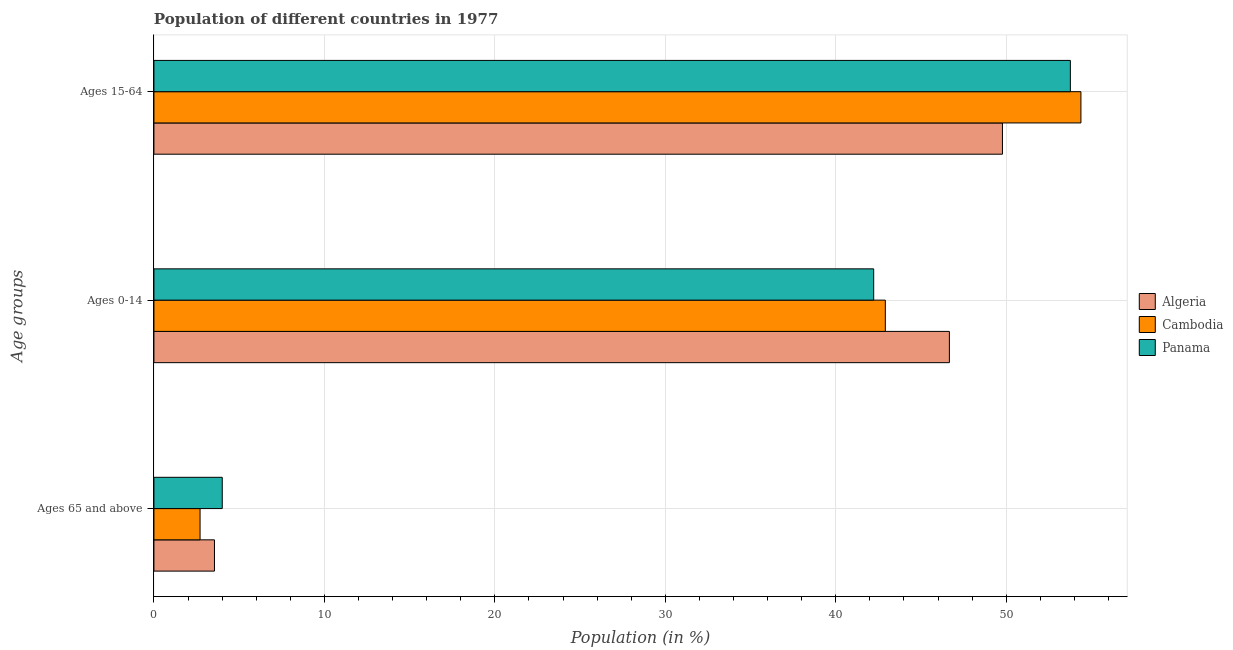Are the number of bars per tick equal to the number of legend labels?
Offer a very short reply. Yes. How many bars are there on the 2nd tick from the top?
Provide a short and direct response. 3. How many bars are there on the 2nd tick from the bottom?
Give a very brief answer. 3. What is the label of the 2nd group of bars from the top?
Provide a short and direct response. Ages 0-14. What is the percentage of population within the age-group 15-64 in Cambodia?
Offer a very short reply. 54.38. Across all countries, what is the maximum percentage of population within the age-group 15-64?
Your answer should be compact. 54.38. Across all countries, what is the minimum percentage of population within the age-group 0-14?
Provide a succinct answer. 42.23. In which country was the percentage of population within the age-group 0-14 maximum?
Give a very brief answer. Algeria. In which country was the percentage of population within the age-group 15-64 minimum?
Your response must be concise. Algeria. What is the total percentage of population within the age-group 15-64 in the graph?
Provide a short and direct response. 157.93. What is the difference between the percentage of population within the age-group 15-64 in Panama and that in Algeria?
Provide a short and direct response. 3.98. What is the difference between the percentage of population within the age-group 0-14 in Algeria and the percentage of population within the age-group of 65 and above in Cambodia?
Offer a very short reply. 43.96. What is the average percentage of population within the age-group of 65 and above per country?
Provide a succinct answer. 3.42. What is the difference between the percentage of population within the age-group 0-14 and percentage of population within the age-group 15-64 in Cambodia?
Offer a very short reply. -11.47. What is the ratio of the percentage of population within the age-group 15-64 in Algeria to that in Panama?
Your response must be concise. 0.93. Is the difference between the percentage of population within the age-group 15-64 in Panama and Algeria greater than the difference between the percentage of population within the age-group 0-14 in Panama and Algeria?
Provide a succinct answer. Yes. What is the difference between the highest and the second highest percentage of population within the age-group 15-64?
Keep it short and to the point. 0.62. What is the difference between the highest and the lowest percentage of population within the age-group of 65 and above?
Ensure brevity in your answer.  1.3. What does the 1st bar from the top in Ages 15-64 represents?
Give a very brief answer. Panama. What does the 3rd bar from the bottom in Ages 15-64 represents?
Ensure brevity in your answer.  Panama. How many bars are there?
Ensure brevity in your answer.  9. What is the difference between two consecutive major ticks on the X-axis?
Provide a succinct answer. 10. Does the graph contain any zero values?
Your answer should be compact. No. Where does the legend appear in the graph?
Provide a short and direct response. Center right. How many legend labels are there?
Keep it short and to the point. 3. How are the legend labels stacked?
Offer a very short reply. Vertical. What is the title of the graph?
Your answer should be compact. Population of different countries in 1977. What is the label or title of the X-axis?
Ensure brevity in your answer.  Population (in %). What is the label or title of the Y-axis?
Offer a terse response. Age groups. What is the Population (in %) of Algeria in Ages 65 and above?
Your response must be concise. 3.55. What is the Population (in %) in Cambodia in Ages 65 and above?
Make the answer very short. 2.71. What is the Population (in %) of Panama in Ages 65 and above?
Your answer should be very brief. 4.01. What is the Population (in %) in Algeria in Ages 0-14?
Provide a succinct answer. 46.67. What is the Population (in %) of Cambodia in Ages 0-14?
Offer a very short reply. 42.91. What is the Population (in %) of Panama in Ages 0-14?
Offer a terse response. 42.23. What is the Population (in %) of Algeria in Ages 15-64?
Provide a succinct answer. 49.78. What is the Population (in %) of Cambodia in Ages 15-64?
Your response must be concise. 54.38. What is the Population (in %) of Panama in Ages 15-64?
Give a very brief answer. 53.76. Across all Age groups, what is the maximum Population (in %) of Algeria?
Your answer should be compact. 49.78. Across all Age groups, what is the maximum Population (in %) of Cambodia?
Make the answer very short. 54.38. Across all Age groups, what is the maximum Population (in %) of Panama?
Keep it short and to the point. 53.76. Across all Age groups, what is the minimum Population (in %) of Algeria?
Offer a terse response. 3.55. Across all Age groups, what is the minimum Population (in %) of Cambodia?
Provide a short and direct response. 2.71. Across all Age groups, what is the minimum Population (in %) in Panama?
Ensure brevity in your answer.  4.01. What is the total Population (in %) of Algeria in the graph?
Keep it short and to the point. 100. What is the total Population (in %) of Cambodia in the graph?
Offer a very short reply. 100. What is the total Population (in %) in Panama in the graph?
Provide a succinct answer. 100. What is the difference between the Population (in %) of Algeria in Ages 65 and above and that in Ages 0-14?
Your response must be concise. -43.12. What is the difference between the Population (in %) of Cambodia in Ages 65 and above and that in Ages 0-14?
Provide a succinct answer. -40.2. What is the difference between the Population (in %) in Panama in Ages 65 and above and that in Ages 0-14?
Offer a terse response. -38.22. What is the difference between the Population (in %) of Algeria in Ages 65 and above and that in Ages 15-64?
Give a very brief answer. -46.23. What is the difference between the Population (in %) of Cambodia in Ages 65 and above and that in Ages 15-64?
Offer a very short reply. -51.68. What is the difference between the Population (in %) in Panama in Ages 65 and above and that in Ages 15-64?
Provide a short and direct response. -49.76. What is the difference between the Population (in %) in Algeria in Ages 0-14 and that in Ages 15-64?
Your answer should be very brief. -3.11. What is the difference between the Population (in %) of Cambodia in Ages 0-14 and that in Ages 15-64?
Your answer should be very brief. -11.47. What is the difference between the Population (in %) in Panama in Ages 0-14 and that in Ages 15-64?
Your answer should be very brief. -11.54. What is the difference between the Population (in %) in Algeria in Ages 65 and above and the Population (in %) in Cambodia in Ages 0-14?
Ensure brevity in your answer.  -39.36. What is the difference between the Population (in %) in Algeria in Ages 65 and above and the Population (in %) in Panama in Ages 0-14?
Your answer should be compact. -38.67. What is the difference between the Population (in %) in Cambodia in Ages 65 and above and the Population (in %) in Panama in Ages 0-14?
Offer a terse response. -39.52. What is the difference between the Population (in %) in Algeria in Ages 65 and above and the Population (in %) in Cambodia in Ages 15-64?
Your answer should be compact. -50.83. What is the difference between the Population (in %) in Algeria in Ages 65 and above and the Population (in %) in Panama in Ages 15-64?
Make the answer very short. -50.21. What is the difference between the Population (in %) of Cambodia in Ages 65 and above and the Population (in %) of Panama in Ages 15-64?
Your answer should be compact. -51.06. What is the difference between the Population (in %) of Algeria in Ages 0-14 and the Population (in %) of Cambodia in Ages 15-64?
Provide a succinct answer. -7.72. What is the difference between the Population (in %) of Algeria in Ages 0-14 and the Population (in %) of Panama in Ages 15-64?
Ensure brevity in your answer.  -7.1. What is the difference between the Population (in %) of Cambodia in Ages 0-14 and the Population (in %) of Panama in Ages 15-64?
Keep it short and to the point. -10.86. What is the average Population (in %) of Algeria per Age groups?
Your response must be concise. 33.33. What is the average Population (in %) of Cambodia per Age groups?
Offer a very short reply. 33.33. What is the average Population (in %) of Panama per Age groups?
Your answer should be very brief. 33.33. What is the difference between the Population (in %) of Algeria and Population (in %) of Cambodia in Ages 65 and above?
Provide a succinct answer. 0.85. What is the difference between the Population (in %) of Algeria and Population (in %) of Panama in Ages 65 and above?
Provide a short and direct response. -0.46. What is the difference between the Population (in %) of Cambodia and Population (in %) of Panama in Ages 65 and above?
Your answer should be very brief. -1.3. What is the difference between the Population (in %) of Algeria and Population (in %) of Cambodia in Ages 0-14?
Provide a short and direct response. 3.76. What is the difference between the Population (in %) of Algeria and Population (in %) of Panama in Ages 0-14?
Offer a very short reply. 4.44. What is the difference between the Population (in %) in Cambodia and Population (in %) in Panama in Ages 0-14?
Keep it short and to the point. 0.68. What is the difference between the Population (in %) in Algeria and Population (in %) in Cambodia in Ages 15-64?
Give a very brief answer. -4.6. What is the difference between the Population (in %) of Algeria and Population (in %) of Panama in Ages 15-64?
Provide a succinct answer. -3.98. What is the difference between the Population (in %) in Cambodia and Population (in %) in Panama in Ages 15-64?
Give a very brief answer. 0.62. What is the ratio of the Population (in %) of Algeria in Ages 65 and above to that in Ages 0-14?
Your answer should be very brief. 0.08. What is the ratio of the Population (in %) of Cambodia in Ages 65 and above to that in Ages 0-14?
Offer a terse response. 0.06. What is the ratio of the Population (in %) in Panama in Ages 65 and above to that in Ages 0-14?
Your answer should be very brief. 0.09. What is the ratio of the Population (in %) of Algeria in Ages 65 and above to that in Ages 15-64?
Your answer should be very brief. 0.07. What is the ratio of the Population (in %) of Cambodia in Ages 65 and above to that in Ages 15-64?
Your answer should be compact. 0.05. What is the ratio of the Population (in %) of Panama in Ages 65 and above to that in Ages 15-64?
Offer a very short reply. 0.07. What is the ratio of the Population (in %) of Algeria in Ages 0-14 to that in Ages 15-64?
Offer a very short reply. 0.94. What is the ratio of the Population (in %) in Cambodia in Ages 0-14 to that in Ages 15-64?
Provide a succinct answer. 0.79. What is the ratio of the Population (in %) in Panama in Ages 0-14 to that in Ages 15-64?
Your answer should be very brief. 0.79. What is the difference between the highest and the second highest Population (in %) of Algeria?
Give a very brief answer. 3.11. What is the difference between the highest and the second highest Population (in %) in Cambodia?
Make the answer very short. 11.47. What is the difference between the highest and the second highest Population (in %) in Panama?
Offer a terse response. 11.54. What is the difference between the highest and the lowest Population (in %) in Algeria?
Your answer should be very brief. 46.23. What is the difference between the highest and the lowest Population (in %) in Cambodia?
Give a very brief answer. 51.68. What is the difference between the highest and the lowest Population (in %) in Panama?
Provide a short and direct response. 49.76. 